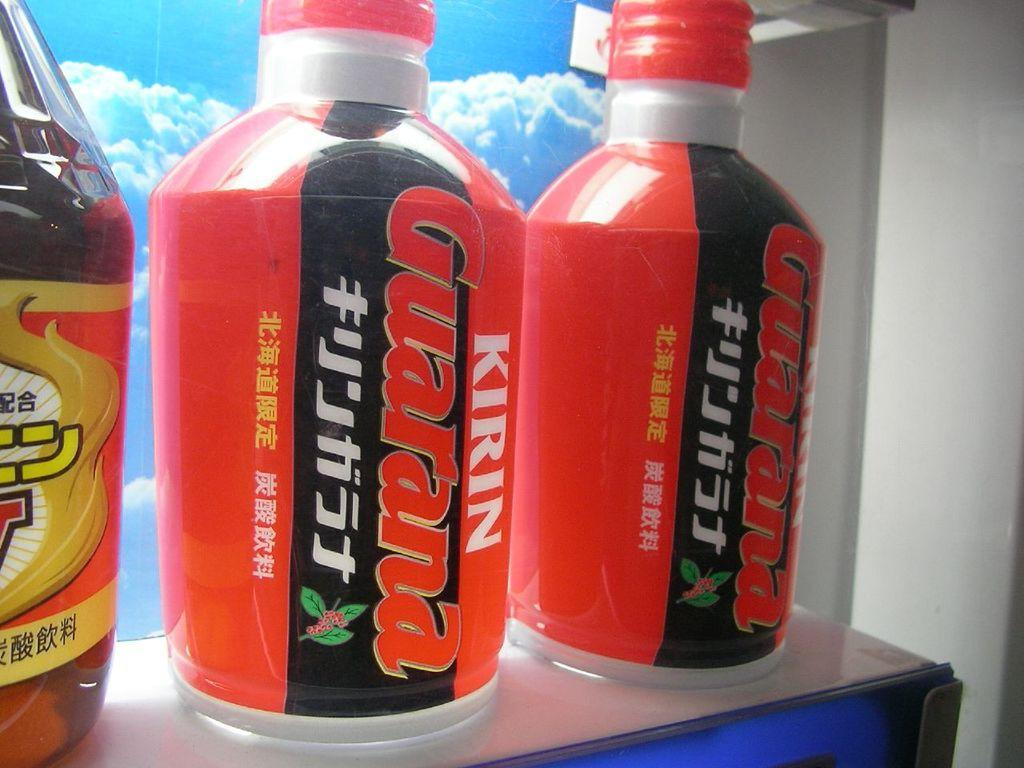What type of beverages are in the bottles in the image? The bottles contain soft drinks. Where are the bottles located in the image? The bottles are present on a table. What type of reaction can be seen from the ring in the image? There is no ring present in the image, so it is not possible to determine any reaction from it. 